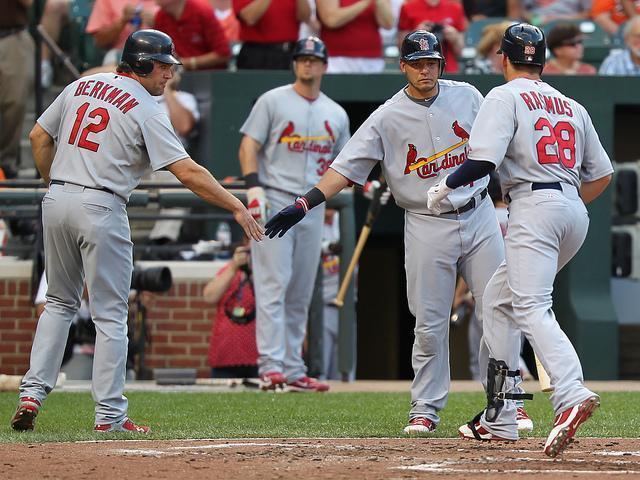How many people are in the photo?
Give a very brief answer. 9. 